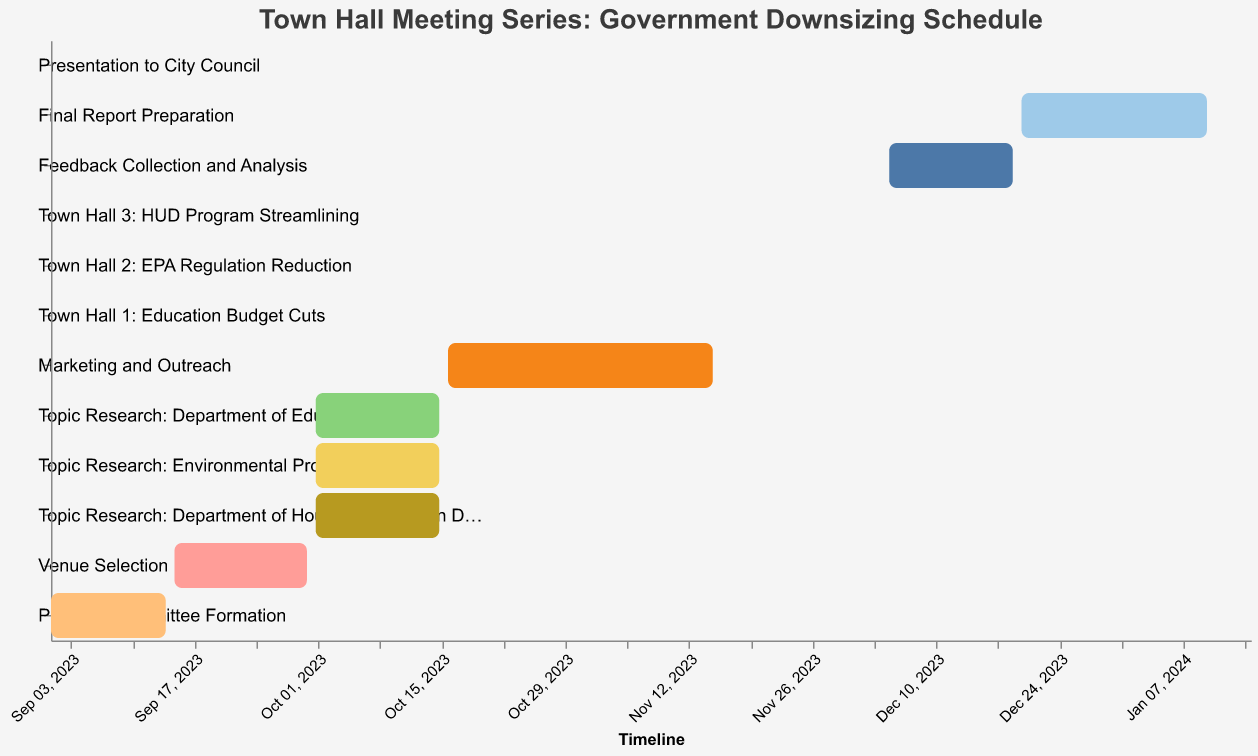How long does the Planning Committee Formation take? The Planning Committee Formation task starts on 2023-09-01 and ends on 2023-09-14. The duration can be calculated as the difference between the end date and the start date.
Answer: 14 days What is the start date for Marketing and Outreach? The Gantt Chart shows that Marketing and Outreach begins on 2023-10-16.
Answer: 2023-10-16 During which dates will Topic Research take place? The Gantt Chart indicates that Topic Research for all three topics (Department of Education, Environmental Protection Agency, and Department of Housing and Urban Development) starts on 2023-10-01 and ends on 2023-10-15.
Answer: 2023-10-01 to 2023-10-15 Which task has the longest duration? By visually comparing the lengths of the bars, the Final Report Preparation task appears to span the longest duration from 2023-12-20 to 2024-01-10.
Answer: Final Report Preparation When is the Presentation to City Council scheduled? The Gantt Chart indicates that the Presentation to City Council is scheduled for a single day on 2024-01-15.
Answer: 2024-01-15 How many days are allocated for Feedback Collection and Analysis? Feedback Collection and Analysis starts on 2023-12-05 and ends on 2023-12-19. The duration is the difference between these two dates.
Answer: 15 days Which tasks occur simultaneously with Topic Research? Topic Research occurs from 2023-10-01 to 2023-10-15. During this time, no other tasks are scheduled to start or end. The tasks that follow immediately after include Marketing and Outreach starting on 2023-10-16.
Answer: None What is the total duration from the start of Planning Committee Formation to the end of Presentation to City Council? The entire duration spans from the start of the Planning Committee Formation on 2023-09-01 to the end of the Presentation to City Council on 2024-01-15. By counting the days, the duration is 137 days.
Answer: 137 days Which task immediately follows the Town Hall meetings? According to the Gantt Chart, the Feedback Collection and Analysis task immediately follows the last Town Hall meeting, starting on 2023-12-05.
Answer: Feedback Collection and Analysis How many Town Hall meetings are scheduled, and when do they take place? The chart indicates three Town Hall meetings are scheduled: Town Hall 1 on 2023-11-20, Town Hall 2 on 2023-11-27, and Town Hall 3 on 2023-12-04.
Answer: 3 meetings: 2023-11-20, 2023-11-27, 2023-12-04 